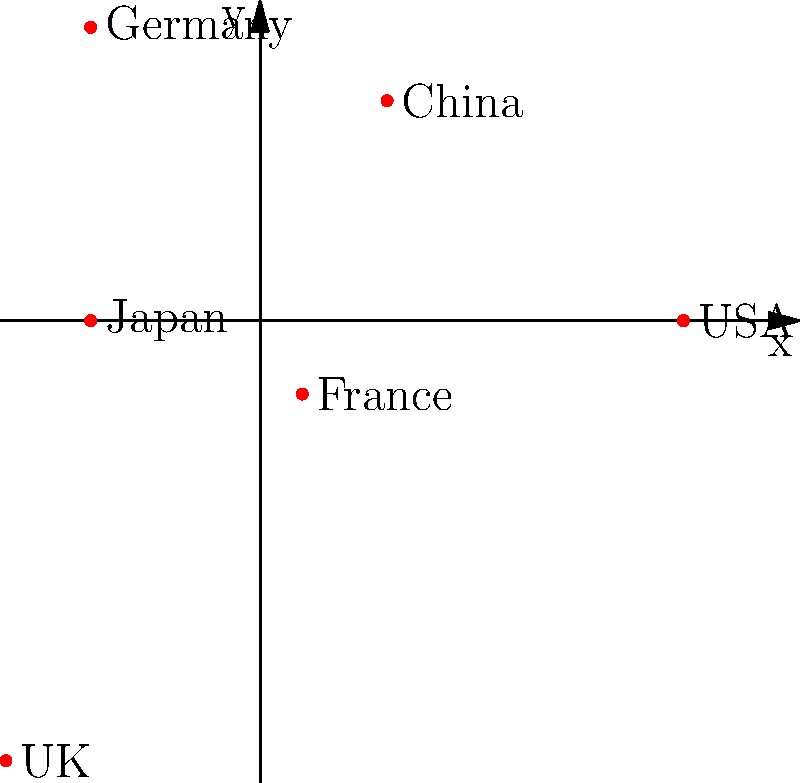In the polar coordinate system shown, trade volumes between countries are represented by their distance from the origin. Based on this representation, which country has the highest trade volume with your firm's home country, and how might this information be relevant in a commercial law context? To answer this question, we need to analyze the polar coordinate plot and understand its implications for commercial law:

1. Interpret the plot:
   - Each point represents a country.
   - The distance from the origin (radius) represents the trade volume.
   - The angular position differentiates between countries.

2. Identify the country with the highest trade volume:
   - Visually compare the distances from the origin.
   - The point furthest from the origin represents the highest trade volume.
   - In this case, the UK has the longest radius.

3. Relevance to commercial law:
   - Higher trade volumes often correlate with more frequent and complex international transactions.
   - This may lead to:
     a) Increased demand for legal services in areas such as contract law, trade regulations, and dispute resolution.
     b) Need for expertise in UK-specific commercial laws and regulations.
     c) Potential for more cross-border litigation or arbitration cases.
     d) Opportunities to specialize in UK-related commercial law matters.

4. Strategic implications for the law firm:
   - Consider allocating more resources to UK-related commercial law practices.
   - Develop stronger relationships with UK-based law firms for potential collaborations.
   - Stay updated on changes in UK commercial laws and trade agreements, especially post-Brexit.

Understanding this trade relationship can help the law firm position itself to better serve clients engaged in high-volume international trade with the UK.
Answer: UK; indicates potential for increased UK-related commercial law services 